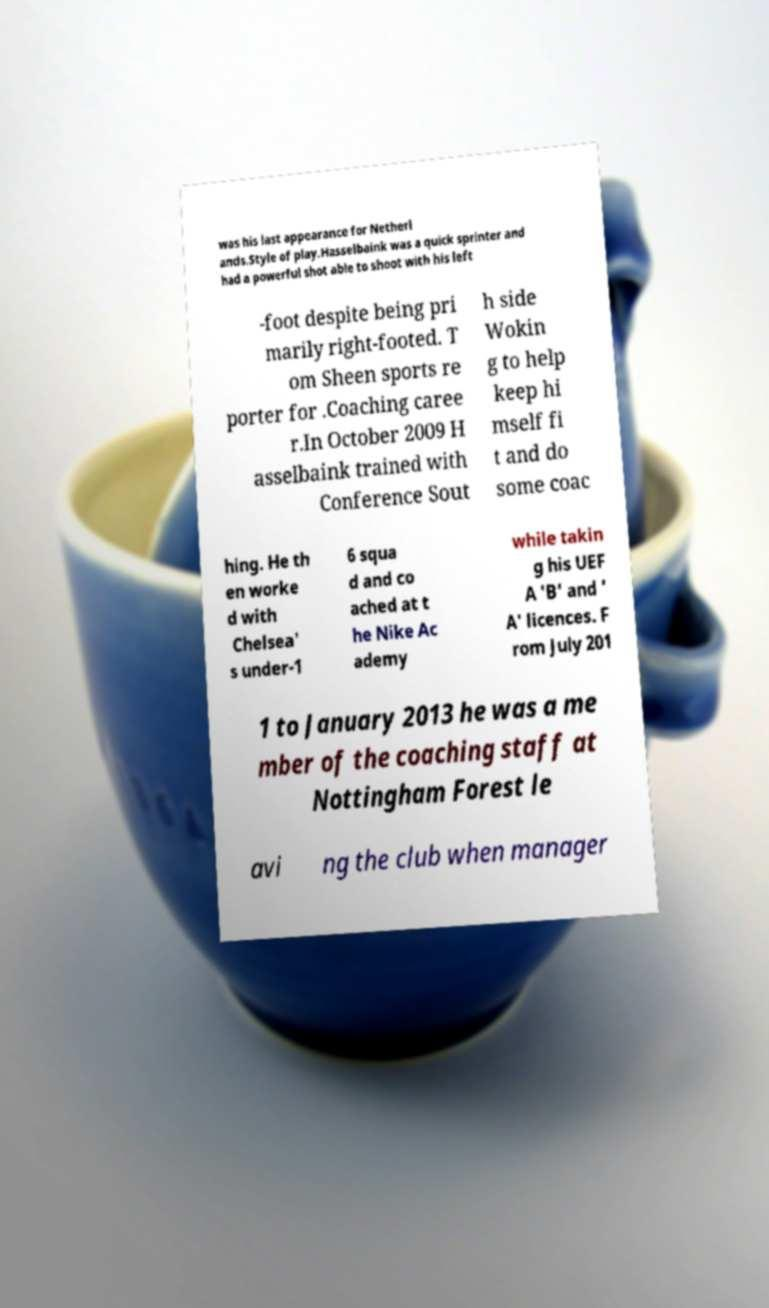There's text embedded in this image that I need extracted. Can you transcribe it verbatim? was his last appearance for Netherl ands.Style of play.Hasselbaink was a quick sprinter and had a powerful shot able to shoot with his left -foot despite being pri marily right-footed. T om Sheen sports re porter for .Coaching caree r.In October 2009 H asselbaink trained with Conference Sout h side Wokin g to help keep hi mself fi t and do some coac hing. He th en worke d with Chelsea' s under-1 6 squa d and co ached at t he Nike Ac ademy while takin g his UEF A 'B' and ' A' licences. F rom July 201 1 to January 2013 he was a me mber of the coaching staff at Nottingham Forest le avi ng the club when manager 